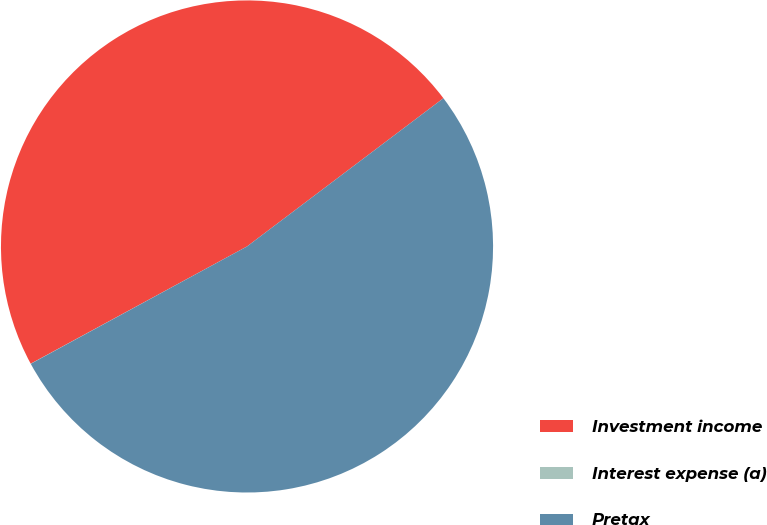Convert chart. <chart><loc_0><loc_0><loc_500><loc_500><pie_chart><fcel>Investment income<fcel>Interest expense (a)<fcel>Pretax<nl><fcel>47.62%<fcel>0.01%<fcel>52.38%<nl></chart> 